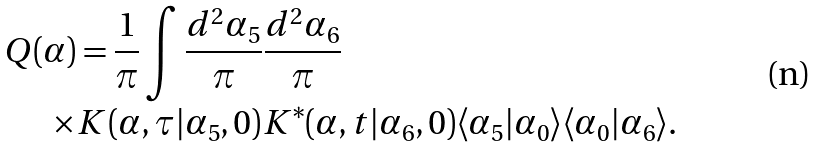Convert formula to latex. <formula><loc_0><loc_0><loc_500><loc_500>Q ( \alpha ) & = \frac { 1 } { \pi } \int \frac { d ^ { 2 } \alpha _ { 5 } } { \pi } \frac { d ^ { 2 } \alpha _ { 6 } } { \pi } \\ \times & K ( \alpha , \tau | \alpha _ { 5 } , 0 ) K ^ { * } ( \alpha , t | \alpha _ { 6 } , 0 ) \langle \alpha _ { 5 } | \alpha _ { 0 } \rangle \langle \alpha _ { 0 } | \alpha _ { 6 } \rangle .</formula> 